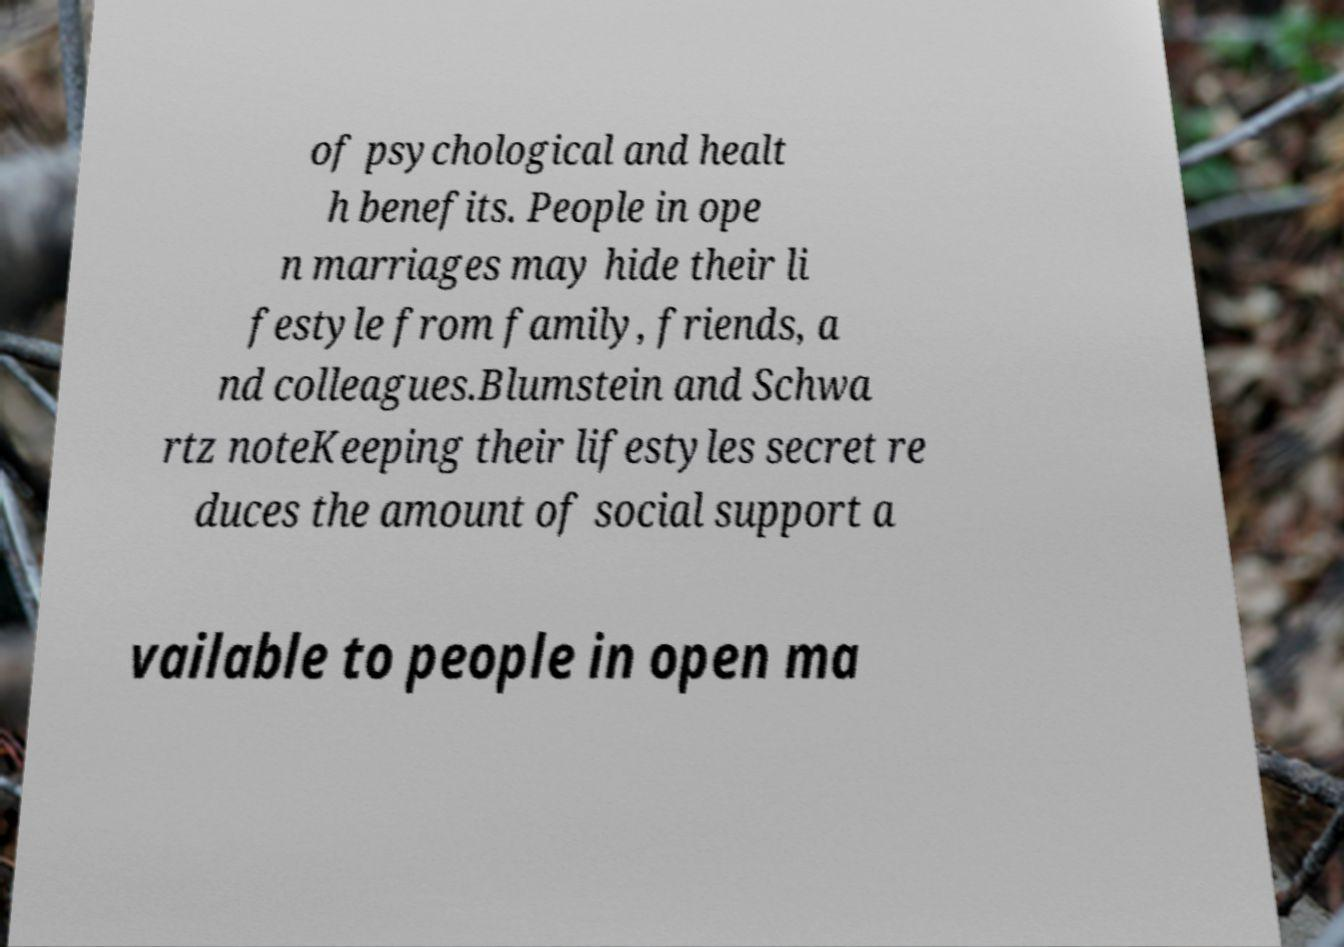There's text embedded in this image that I need extracted. Can you transcribe it verbatim? of psychological and healt h benefits. People in ope n marriages may hide their li festyle from family, friends, a nd colleagues.Blumstein and Schwa rtz noteKeeping their lifestyles secret re duces the amount of social support a vailable to people in open ma 